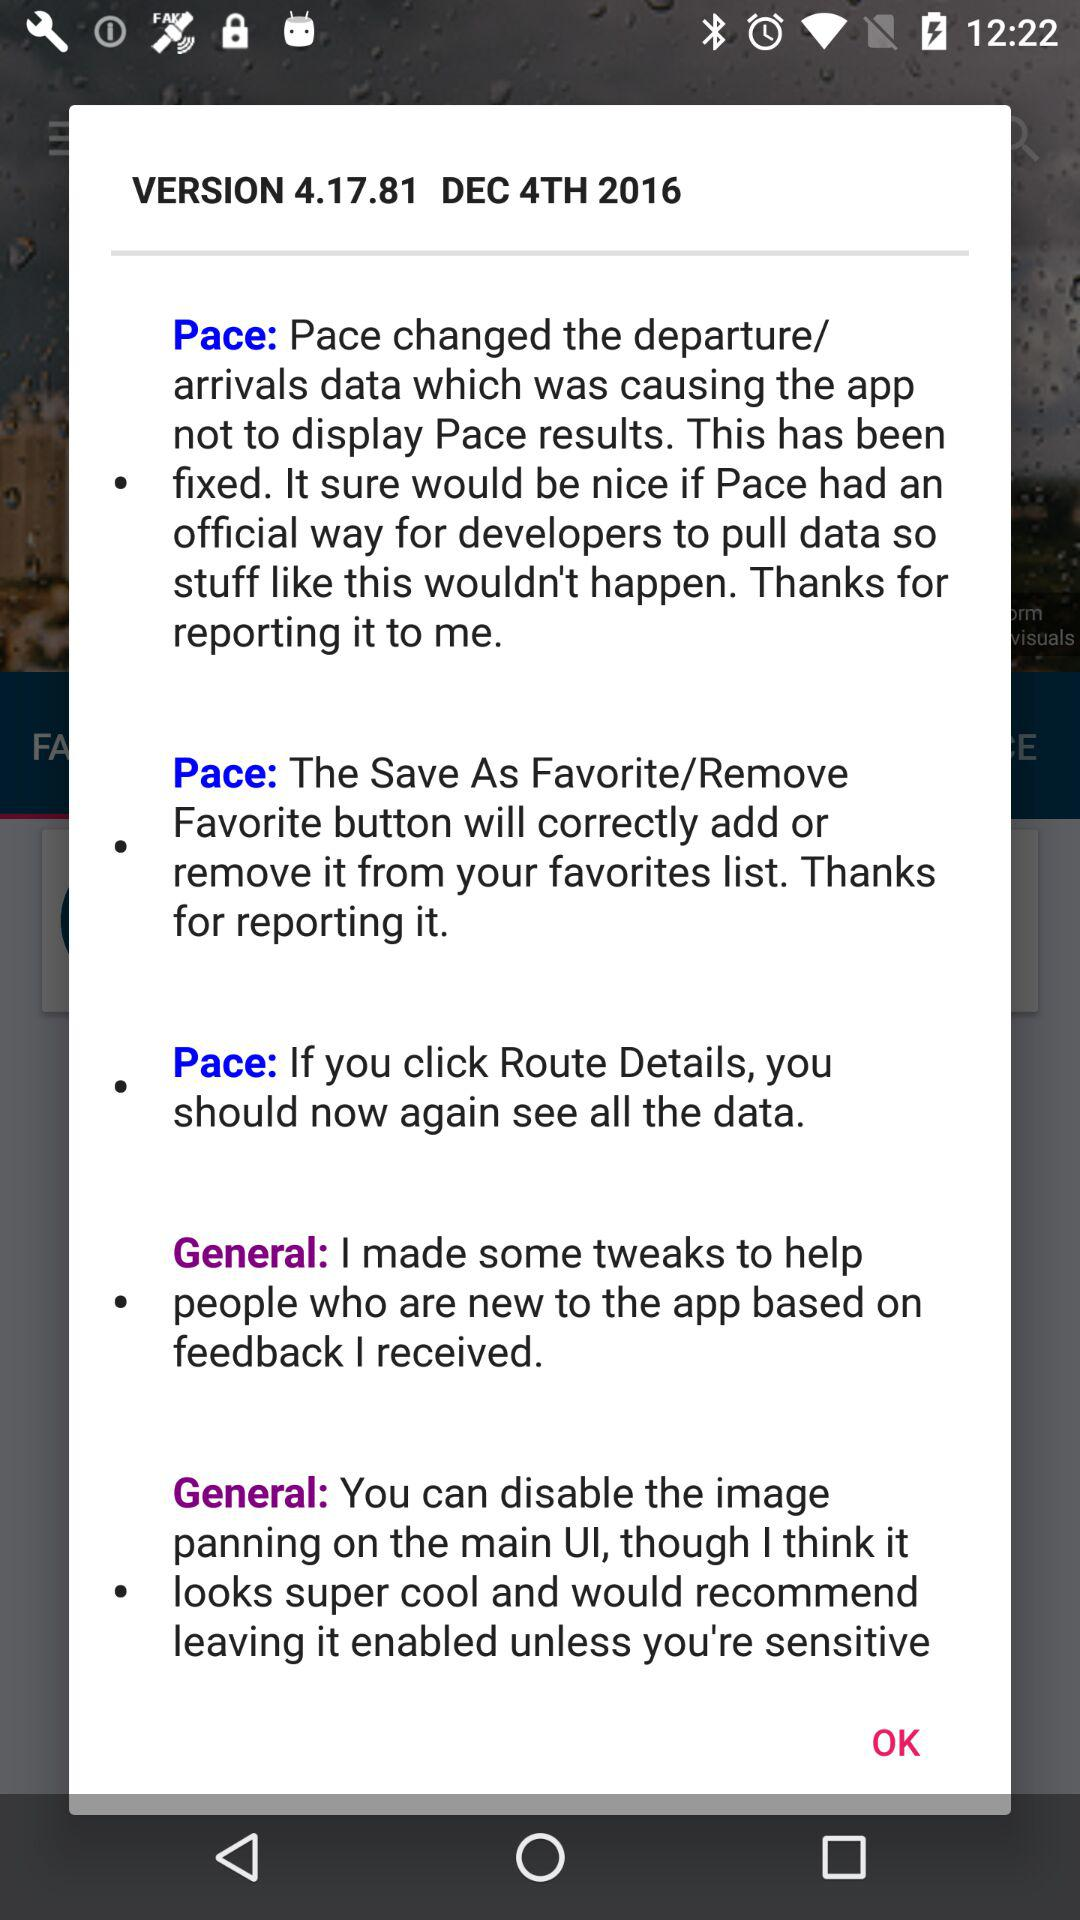What is the date? The date is December 4, 2016. 